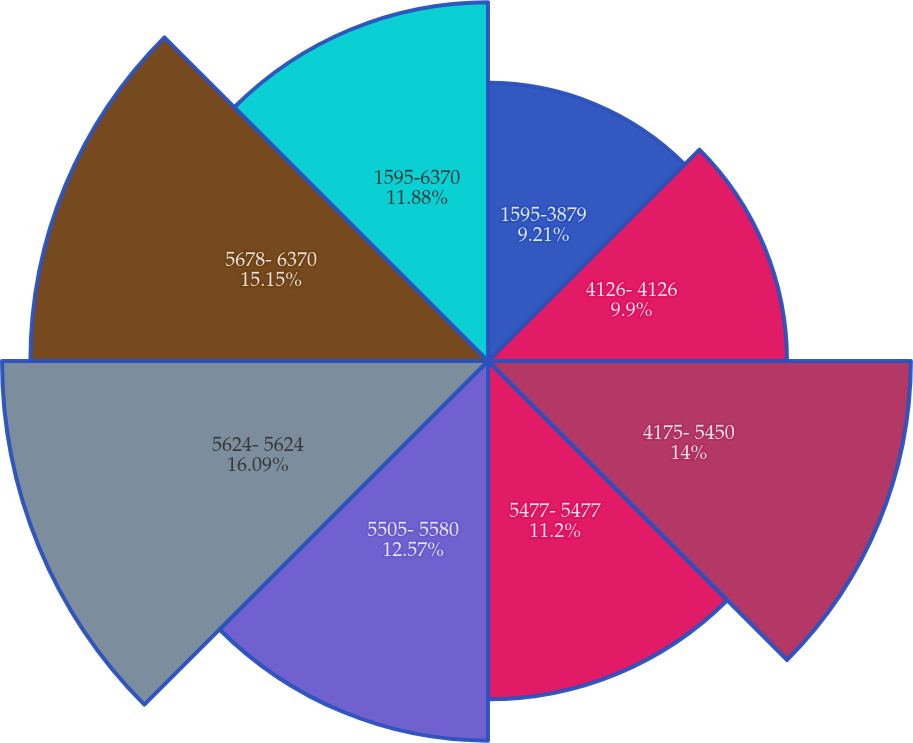Convert chart. <chart><loc_0><loc_0><loc_500><loc_500><pie_chart><fcel>1595-3879<fcel>4126- 4126<fcel>4175- 5450<fcel>5477- 5477<fcel>5505- 5580<fcel>5624- 5624<fcel>5678- 6370<fcel>1595-6370<nl><fcel>9.21%<fcel>9.9%<fcel>14.0%<fcel>11.2%<fcel>12.57%<fcel>16.09%<fcel>15.15%<fcel>11.88%<nl></chart> 